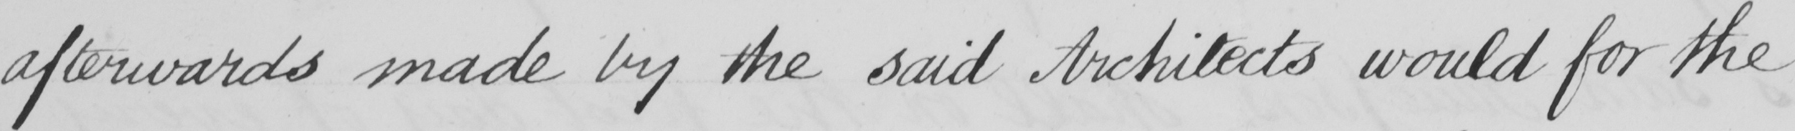Can you read and transcribe this handwriting? afterwards made by the said Architects would for the 